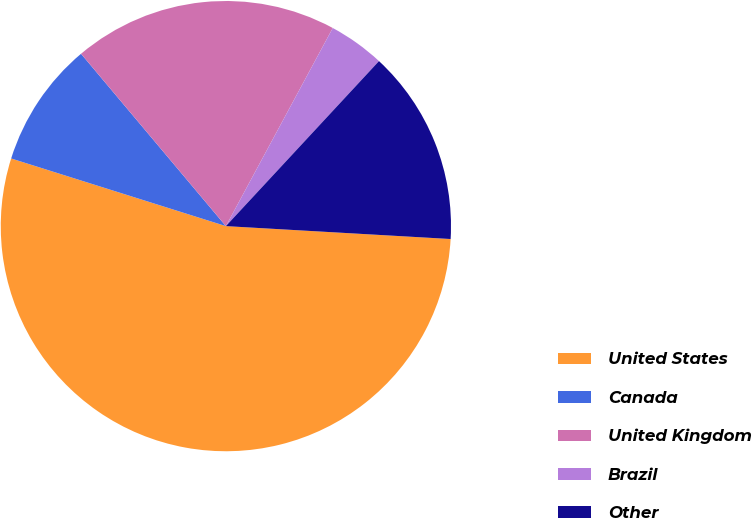Convert chart. <chart><loc_0><loc_0><loc_500><loc_500><pie_chart><fcel>United States<fcel>Canada<fcel>United Kingdom<fcel>Brazil<fcel>Other<nl><fcel>53.95%<fcel>9.02%<fcel>19.0%<fcel>4.03%<fcel>14.01%<nl></chart> 